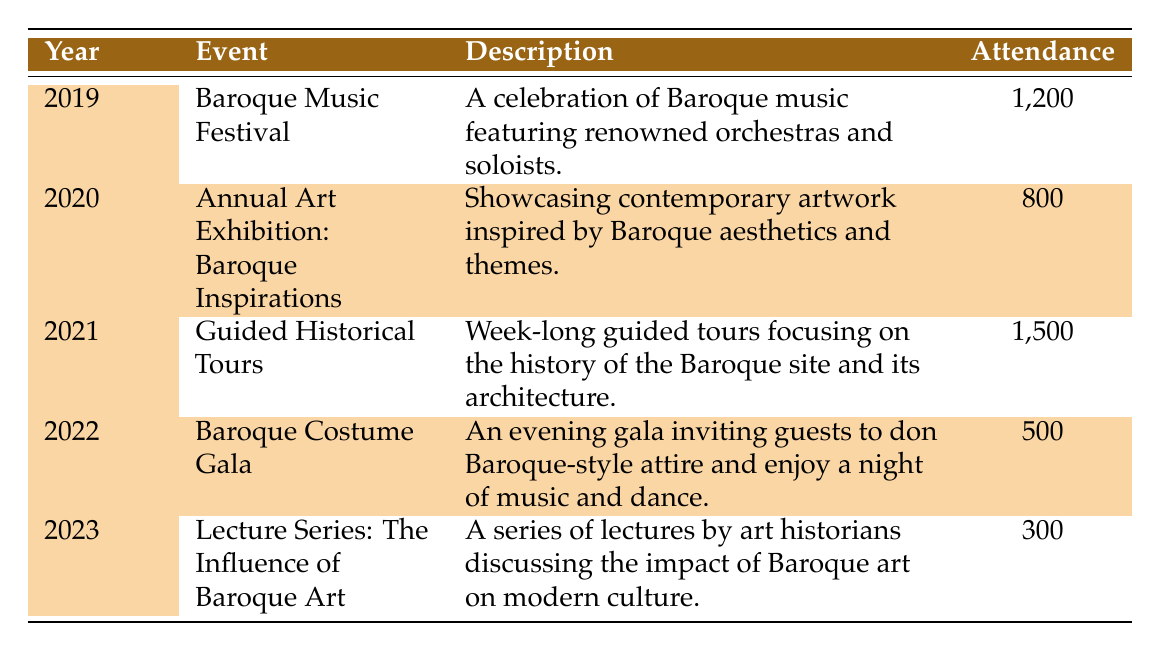What event had the highest attendance? The event with the highest attendance can be found by looking at the Attendance column. Comparing the attendance numbers, the Guided Historical Tours in 2021 had the most attendees at 1500.
Answer: Guided Historical Tours How many people attended the Baroque Costume Gala in 2022? The Baroque Costume Gala is noted in the table under the Year 2022 with an Attendance figure of 500.
Answer: 500 Was there a cultural event in 2023? Yes, there is an event listed for 2023, which is the Lecture Series: The Influence of Baroque Art. Therefore, the answer is yes.
Answer: Yes What is the total attendance for events held between 2019 and 2021? To find the total attendance, we add the attendance numbers for 2019, 2020, and 2021: 1200 (2019) + 800 (2020) + 1500 (2021) = 3500.
Answer: 3500 Did the attendance increase in 2021 compared to 2020? The attendance in 2020 was 800 and in 2021 was 1500. Since 1500 is greater than 800, we conclude that attendance did indeed increase.
Answer: Yes What is the average attendance for events held from 2019 to 2022? The attendance numbers for these years are 1200 (2019), 800 (2020), 1500 (2021), and 500 (2022). The sum of these attendances is 1200 + 800 + 1500 + 500 = 3000. There are four events, so the average attendance is 3000 divided by 4, which equals 750.
Answer: 750 Which event had the lowest attendance? Reviewing the Attendance column, the event with the lowest number is the Lecture Series: The Influence of Baroque Art in 2023, which had 300 attendees.
Answer: Lecture Series: The Influence of Baroque Art Were there any events with an attendance of over 1000? Checking through the attendance numbers, the events that meet this criterion are the Baroque Music Festival with 1200 and the Guided Historical Tours with 1500, indicating there were indeed events with over 1000 attendees.
Answer: Yes What was the attendance difference between the Baroque Music Festival and the Annual Art Exhibition: Baroque Inspirations? The attendance for the Baroque Music Festival in 2019 was 1200 and for the Annual Art Exhibition in 2020 was 800. The difference in attendance is calculated as 1200 - 800 = 400.
Answer: 400 